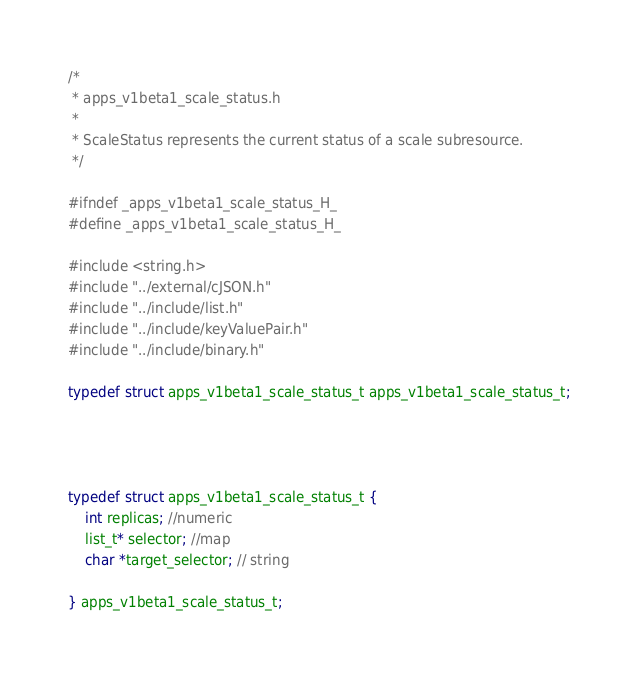Convert code to text. <code><loc_0><loc_0><loc_500><loc_500><_C_>/*
 * apps_v1beta1_scale_status.h
 *
 * ScaleStatus represents the current status of a scale subresource.
 */

#ifndef _apps_v1beta1_scale_status_H_
#define _apps_v1beta1_scale_status_H_

#include <string.h>
#include "../external/cJSON.h"
#include "../include/list.h"
#include "../include/keyValuePair.h"
#include "../include/binary.h"

typedef struct apps_v1beta1_scale_status_t apps_v1beta1_scale_status_t;




typedef struct apps_v1beta1_scale_status_t {
    int replicas; //numeric
    list_t* selector; //map
    char *target_selector; // string

} apps_v1beta1_scale_status_t;
</code> 